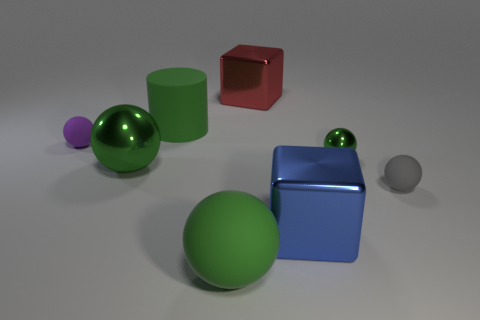Subtract all green spheres. How many were subtracted if there are1green spheres left? 2 Subtract all small green spheres. How many spheres are left? 4 Subtract 2 spheres. How many spheres are left? 3 Subtract all yellow cylinders. How many green spheres are left? 3 Add 2 rubber cylinders. How many objects exist? 10 Subtract all purple spheres. How many spheres are left? 4 Subtract all cyan balls. Subtract all yellow cubes. How many balls are left? 5 Add 3 purple matte objects. How many purple matte objects exist? 4 Subtract 0 blue cylinders. How many objects are left? 8 Subtract all cylinders. How many objects are left? 7 